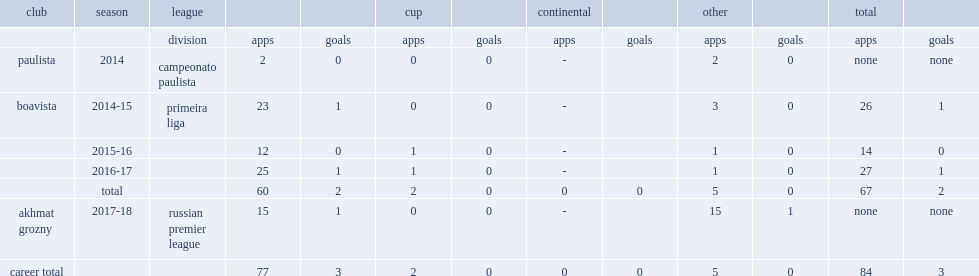Which league did philipe sampaio play for in the 2014 campeonato paulista? Campeonato paulista. 